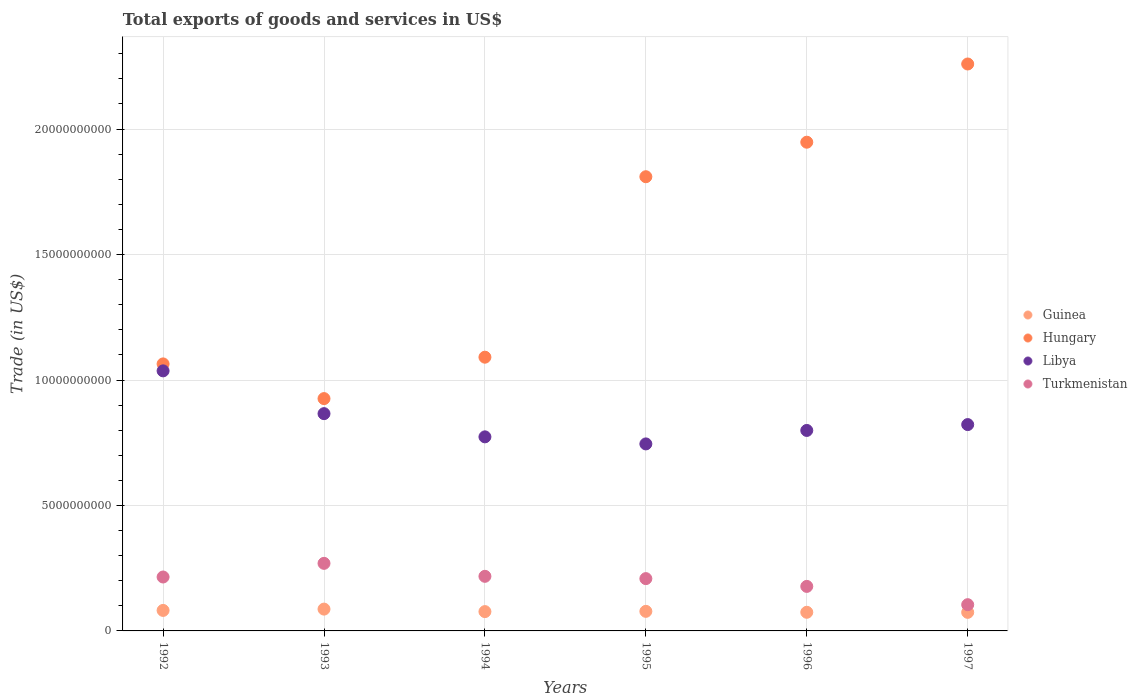How many different coloured dotlines are there?
Ensure brevity in your answer.  4. What is the total exports of goods and services in Libya in 1997?
Provide a short and direct response. 8.22e+09. Across all years, what is the maximum total exports of goods and services in Guinea?
Keep it short and to the point. 8.70e+08. Across all years, what is the minimum total exports of goods and services in Hungary?
Ensure brevity in your answer.  9.26e+09. In which year was the total exports of goods and services in Turkmenistan minimum?
Offer a terse response. 1997. What is the total total exports of goods and services in Hungary in the graph?
Make the answer very short. 9.10e+1. What is the difference between the total exports of goods and services in Hungary in 1993 and that in 1997?
Offer a terse response. -1.33e+1. What is the difference between the total exports of goods and services in Guinea in 1994 and the total exports of goods and services in Turkmenistan in 1997?
Make the answer very short. -2.76e+08. What is the average total exports of goods and services in Turkmenistan per year?
Offer a very short reply. 1.99e+09. In the year 1997, what is the difference between the total exports of goods and services in Guinea and total exports of goods and services in Hungary?
Provide a succinct answer. -2.19e+1. What is the ratio of the total exports of goods and services in Guinea in 1993 to that in 1997?
Provide a short and direct response. 1.17. Is the total exports of goods and services in Libya in 1993 less than that in 1996?
Ensure brevity in your answer.  No. Is the difference between the total exports of goods and services in Guinea in 1993 and 1997 greater than the difference between the total exports of goods and services in Hungary in 1993 and 1997?
Provide a succinct answer. Yes. What is the difference between the highest and the second highest total exports of goods and services in Libya?
Keep it short and to the point. 1.70e+09. What is the difference between the highest and the lowest total exports of goods and services in Libya?
Offer a terse response. 2.91e+09. In how many years, is the total exports of goods and services in Hungary greater than the average total exports of goods and services in Hungary taken over all years?
Your response must be concise. 3. Is it the case that in every year, the sum of the total exports of goods and services in Hungary and total exports of goods and services in Libya  is greater than the sum of total exports of goods and services in Guinea and total exports of goods and services in Turkmenistan?
Keep it short and to the point. No. Is it the case that in every year, the sum of the total exports of goods and services in Guinea and total exports of goods and services in Hungary  is greater than the total exports of goods and services in Turkmenistan?
Provide a succinct answer. Yes. Is the total exports of goods and services in Guinea strictly greater than the total exports of goods and services in Libya over the years?
Make the answer very short. No. What is the difference between two consecutive major ticks on the Y-axis?
Provide a succinct answer. 5.00e+09. Does the graph contain any zero values?
Provide a short and direct response. No. Does the graph contain grids?
Provide a short and direct response. Yes. How many legend labels are there?
Provide a short and direct response. 4. How are the legend labels stacked?
Offer a terse response. Vertical. What is the title of the graph?
Your answer should be compact. Total exports of goods and services in US$. Does "Belize" appear as one of the legend labels in the graph?
Your answer should be compact. No. What is the label or title of the Y-axis?
Offer a terse response. Trade (in US$). What is the Trade (in US$) of Guinea in 1992?
Your answer should be very brief. 8.17e+08. What is the Trade (in US$) of Hungary in 1992?
Provide a short and direct response. 1.06e+1. What is the Trade (in US$) of Libya in 1992?
Make the answer very short. 1.04e+1. What is the Trade (in US$) of Turkmenistan in 1992?
Your response must be concise. 2.15e+09. What is the Trade (in US$) of Guinea in 1993?
Your answer should be very brief. 8.70e+08. What is the Trade (in US$) of Hungary in 1993?
Your response must be concise. 9.26e+09. What is the Trade (in US$) in Libya in 1993?
Your response must be concise. 8.66e+09. What is the Trade (in US$) in Turkmenistan in 1993?
Your answer should be very brief. 2.69e+09. What is the Trade (in US$) of Guinea in 1994?
Your answer should be compact. 7.70e+08. What is the Trade (in US$) of Hungary in 1994?
Your answer should be very brief. 1.09e+1. What is the Trade (in US$) of Libya in 1994?
Provide a short and direct response. 7.73e+09. What is the Trade (in US$) of Turkmenistan in 1994?
Give a very brief answer. 2.18e+09. What is the Trade (in US$) in Guinea in 1995?
Offer a terse response. 7.80e+08. What is the Trade (in US$) of Hungary in 1995?
Provide a short and direct response. 1.81e+1. What is the Trade (in US$) of Libya in 1995?
Provide a succinct answer. 7.45e+09. What is the Trade (in US$) in Turkmenistan in 1995?
Provide a succinct answer. 2.08e+09. What is the Trade (in US$) in Guinea in 1996?
Your answer should be very brief. 7.43e+08. What is the Trade (in US$) in Hungary in 1996?
Provide a succinct answer. 1.95e+1. What is the Trade (in US$) of Libya in 1996?
Provide a short and direct response. 7.99e+09. What is the Trade (in US$) in Turkmenistan in 1996?
Provide a short and direct response. 1.77e+09. What is the Trade (in US$) of Guinea in 1997?
Make the answer very short. 7.40e+08. What is the Trade (in US$) of Hungary in 1997?
Offer a very short reply. 2.26e+1. What is the Trade (in US$) of Libya in 1997?
Ensure brevity in your answer.  8.22e+09. What is the Trade (in US$) of Turkmenistan in 1997?
Give a very brief answer. 1.05e+09. Across all years, what is the maximum Trade (in US$) in Guinea?
Your answer should be very brief. 8.70e+08. Across all years, what is the maximum Trade (in US$) in Hungary?
Keep it short and to the point. 2.26e+1. Across all years, what is the maximum Trade (in US$) in Libya?
Keep it short and to the point. 1.04e+1. Across all years, what is the maximum Trade (in US$) of Turkmenistan?
Offer a terse response. 2.69e+09. Across all years, what is the minimum Trade (in US$) in Guinea?
Give a very brief answer. 7.40e+08. Across all years, what is the minimum Trade (in US$) in Hungary?
Offer a terse response. 9.26e+09. Across all years, what is the minimum Trade (in US$) of Libya?
Provide a succinct answer. 7.45e+09. Across all years, what is the minimum Trade (in US$) of Turkmenistan?
Keep it short and to the point. 1.05e+09. What is the total Trade (in US$) in Guinea in the graph?
Ensure brevity in your answer.  4.72e+09. What is the total Trade (in US$) of Hungary in the graph?
Ensure brevity in your answer.  9.10e+1. What is the total Trade (in US$) in Libya in the graph?
Provide a short and direct response. 5.04e+1. What is the total Trade (in US$) in Turkmenistan in the graph?
Make the answer very short. 1.19e+1. What is the difference between the Trade (in US$) of Guinea in 1992 and that in 1993?
Your answer should be very brief. -5.25e+07. What is the difference between the Trade (in US$) of Hungary in 1992 and that in 1993?
Give a very brief answer. 1.38e+09. What is the difference between the Trade (in US$) of Libya in 1992 and that in 1993?
Offer a terse response. 1.70e+09. What is the difference between the Trade (in US$) in Turkmenistan in 1992 and that in 1993?
Keep it short and to the point. -5.44e+08. What is the difference between the Trade (in US$) in Guinea in 1992 and that in 1994?
Offer a very short reply. 4.73e+07. What is the difference between the Trade (in US$) of Hungary in 1992 and that in 1994?
Ensure brevity in your answer.  -2.68e+08. What is the difference between the Trade (in US$) in Libya in 1992 and that in 1994?
Your answer should be compact. 2.63e+09. What is the difference between the Trade (in US$) of Turkmenistan in 1992 and that in 1994?
Your answer should be very brief. -2.69e+07. What is the difference between the Trade (in US$) in Guinea in 1992 and that in 1995?
Ensure brevity in your answer.  3.70e+07. What is the difference between the Trade (in US$) of Hungary in 1992 and that in 1995?
Provide a succinct answer. -7.46e+09. What is the difference between the Trade (in US$) of Libya in 1992 and that in 1995?
Your answer should be compact. 2.91e+09. What is the difference between the Trade (in US$) of Turkmenistan in 1992 and that in 1995?
Offer a very short reply. 6.45e+07. What is the difference between the Trade (in US$) in Guinea in 1992 and that in 1996?
Give a very brief answer. 7.44e+07. What is the difference between the Trade (in US$) in Hungary in 1992 and that in 1996?
Offer a terse response. -8.84e+09. What is the difference between the Trade (in US$) of Libya in 1992 and that in 1996?
Your response must be concise. 2.37e+09. What is the difference between the Trade (in US$) of Turkmenistan in 1992 and that in 1996?
Keep it short and to the point. 3.74e+08. What is the difference between the Trade (in US$) of Guinea in 1992 and that in 1997?
Your answer should be very brief. 7.69e+07. What is the difference between the Trade (in US$) in Hungary in 1992 and that in 1997?
Provide a succinct answer. -1.20e+1. What is the difference between the Trade (in US$) in Libya in 1992 and that in 1997?
Offer a very short reply. 2.14e+09. What is the difference between the Trade (in US$) in Turkmenistan in 1992 and that in 1997?
Your answer should be compact. 1.10e+09. What is the difference between the Trade (in US$) of Guinea in 1993 and that in 1994?
Offer a very short reply. 9.98e+07. What is the difference between the Trade (in US$) of Hungary in 1993 and that in 1994?
Your answer should be very brief. -1.65e+09. What is the difference between the Trade (in US$) of Libya in 1993 and that in 1994?
Make the answer very short. 9.25e+08. What is the difference between the Trade (in US$) in Turkmenistan in 1993 and that in 1994?
Keep it short and to the point. 5.17e+08. What is the difference between the Trade (in US$) in Guinea in 1993 and that in 1995?
Provide a short and direct response. 8.95e+07. What is the difference between the Trade (in US$) in Hungary in 1993 and that in 1995?
Offer a very short reply. -8.84e+09. What is the difference between the Trade (in US$) of Libya in 1993 and that in 1995?
Keep it short and to the point. 1.21e+09. What is the difference between the Trade (in US$) in Turkmenistan in 1993 and that in 1995?
Provide a succinct answer. 6.08e+08. What is the difference between the Trade (in US$) in Guinea in 1993 and that in 1996?
Your response must be concise. 1.27e+08. What is the difference between the Trade (in US$) in Hungary in 1993 and that in 1996?
Offer a terse response. -1.02e+1. What is the difference between the Trade (in US$) of Libya in 1993 and that in 1996?
Your answer should be very brief. 6.69e+08. What is the difference between the Trade (in US$) in Turkmenistan in 1993 and that in 1996?
Offer a terse response. 9.18e+08. What is the difference between the Trade (in US$) of Guinea in 1993 and that in 1997?
Provide a succinct answer. 1.29e+08. What is the difference between the Trade (in US$) in Hungary in 1993 and that in 1997?
Keep it short and to the point. -1.33e+1. What is the difference between the Trade (in US$) of Libya in 1993 and that in 1997?
Offer a terse response. 4.36e+08. What is the difference between the Trade (in US$) in Turkmenistan in 1993 and that in 1997?
Your answer should be compact. 1.65e+09. What is the difference between the Trade (in US$) in Guinea in 1994 and that in 1995?
Offer a terse response. -1.03e+07. What is the difference between the Trade (in US$) in Hungary in 1994 and that in 1995?
Provide a short and direct response. -7.19e+09. What is the difference between the Trade (in US$) in Libya in 1994 and that in 1995?
Provide a short and direct response. 2.81e+08. What is the difference between the Trade (in US$) of Turkmenistan in 1994 and that in 1995?
Provide a short and direct response. 9.14e+07. What is the difference between the Trade (in US$) of Guinea in 1994 and that in 1996?
Ensure brevity in your answer.  2.71e+07. What is the difference between the Trade (in US$) in Hungary in 1994 and that in 1996?
Provide a short and direct response. -8.57e+09. What is the difference between the Trade (in US$) in Libya in 1994 and that in 1996?
Give a very brief answer. -2.56e+08. What is the difference between the Trade (in US$) in Turkmenistan in 1994 and that in 1996?
Your answer should be very brief. 4.01e+08. What is the difference between the Trade (in US$) in Guinea in 1994 and that in 1997?
Offer a terse response. 2.96e+07. What is the difference between the Trade (in US$) of Hungary in 1994 and that in 1997?
Your response must be concise. -1.17e+1. What is the difference between the Trade (in US$) in Libya in 1994 and that in 1997?
Offer a very short reply. -4.89e+08. What is the difference between the Trade (in US$) in Turkmenistan in 1994 and that in 1997?
Offer a very short reply. 1.13e+09. What is the difference between the Trade (in US$) of Guinea in 1995 and that in 1996?
Your response must be concise. 3.74e+07. What is the difference between the Trade (in US$) in Hungary in 1995 and that in 1996?
Offer a very short reply. -1.38e+09. What is the difference between the Trade (in US$) of Libya in 1995 and that in 1996?
Your answer should be compact. -5.37e+08. What is the difference between the Trade (in US$) of Turkmenistan in 1995 and that in 1996?
Offer a very short reply. 3.10e+08. What is the difference between the Trade (in US$) of Guinea in 1995 and that in 1997?
Your answer should be compact. 3.99e+07. What is the difference between the Trade (in US$) of Hungary in 1995 and that in 1997?
Offer a very short reply. -4.49e+09. What is the difference between the Trade (in US$) in Libya in 1995 and that in 1997?
Provide a short and direct response. -7.70e+08. What is the difference between the Trade (in US$) in Turkmenistan in 1995 and that in 1997?
Offer a very short reply. 1.04e+09. What is the difference between the Trade (in US$) in Guinea in 1996 and that in 1997?
Offer a very short reply. 2.51e+06. What is the difference between the Trade (in US$) of Hungary in 1996 and that in 1997?
Your answer should be very brief. -3.12e+09. What is the difference between the Trade (in US$) in Libya in 1996 and that in 1997?
Your answer should be very brief. -2.33e+08. What is the difference between the Trade (in US$) of Turkmenistan in 1996 and that in 1997?
Offer a very short reply. 7.29e+08. What is the difference between the Trade (in US$) in Guinea in 1992 and the Trade (in US$) in Hungary in 1993?
Offer a very short reply. -8.44e+09. What is the difference between the Trade (in US$) in Guinea in 1992 and the Trade (in US$) in Libya in 1993?
Offer a very short reply. -7.84e+09. What is the difference between the Trade (in US$) of Guinea in 1992 and the Trade (in US$) of Turkmenistan in 1993?
Make the answer very short. -1.88e+09. What is the difference between the Trade (in US$) in Hungary in 1992 and the Trade (in US$) in Libya in 1993?
Provide a succinct answer. 1.98e+09. What is the difference between the Trade (in US$) of Hungary in 1992 and the Trade (in US$) of Turkmenistan in 1993?
Offer a terse response. 7.95e+09. What is the difference between the Trade (in US$) of Libya in 1992 and the Trade (in US$) of Turkmenistan in 1993?
Make the answer very short. 7.67e+09. What is the difference between the Trade (in US$) in Guinea in 1992 and the Trade (in US$) in Hungary in 1994?
Your answer should be very brief. -1.01e+1. What is the difference between the Trade (in US$) of Guinea in 1992 and the Trade (in US$) of Libya in 1994?
Keep it short and to the point. -6.92e+09. What is the difference between the Trade (in US$) of Guinea in 1992 and the Trade (in US$) of Turkmenistan in 1994?
Offer a terse response. -1.36e+09. What is the difference between the Trade (in US$) of Hungary in 1992 and the Trade (in US$) of Libya in 1994?
Provide a succinct answer. 2.91e+09. What is the difference between the Trade (in US$) in Hungary in 1992 and the Trade (in US$) in Turkmenistan in 1994?
Give a very brief answer. 8.47e+09. What is the difference between the Trade (in US$) in Libya in 1992 and the Trade (in US$) in Turkmenistan in 1994?
Provide a short and direct response. 8.19e+09. What is the difference between the Trade (in US$) of Guinea in 1992 and the Trade (in US$) of Hungary in 1995?
Keep it short and to the point. -1.73e+1. What is the difference between the Trade (in US$) in Guinea in 1992 and the Trade (in US$) in Libya in 1995?
Offer a terse response. -6.64e+09. What is the difference between the Trade (in US$) of Guinea in 1992 and the Trade (in US$) of Turkmenistan in 1995?
Your answer should be very brief. -1.27e+09. What is the difference between the Trade (in US$) of Hungary in 1992 and the Trade (in US$) of Libya in 1995?
Keep it short and to the point. 3.19e+09. What is the difference between the Trade (in US$) in Hungary in 1992 and the Trade (in US$) in Turkmenistan in 1995?
Give a very brief answer. 8.56e+09. What is the difference between the Trade (in US$) in Libya in 1992 and the Trade (in US$) in Turkmenistan in 1995?
Provide a succinct answer. 8.28e+09. What is the difference between the Trade (in US$) of Guinea in 1992 and the Trade (in US$) of Hungary in 1996?
Offer a very short reply. -1.87e+1. What is the difference between the Trade (in US$) of Guinea in 1992 and the Trade (in US$) of Libya in 1996?
Ensure brevity in your answer.  -7.17e+09. What is the difference between the Trade (in US$) of Guinea in 1992 and the Trade (in US$) of Turkmenistan in 1996?
Offer a very short reply. -9.57e+08. What is the difference between the Trade (in US$) in Hungary in 1992 and the Trade (in US$) in Libya in 1996?
Give a very brief answer. 2.65e+09. What is the difference between the Trade (in US$) of Hungary in 1992 and the Trade (in US$) of Turkmenistan in 1996?
Ensure brevity in your answer.  8.87e+09. What is the difference between the Trade (in US$) in Libya in 1992 and the Trade (in US$) in Turkmenistan in 1996?
Provide a short and direct response. 8.59e+09. What is the difference between the Trade (in US$) of Guinea in 1992 and the Trade (in US$) of Hungary in 1997?
Make the answer very short. -2.18e+1. What is the difference between the Trade (in US$) of Guinea in 1992 and the Trade (in US$) of Libya in 1997?
Make the answer very short. -7.41e+09. What is the difference between the Trade (in US$) of Guinea in 1992 and the Trade (in US$) of Turkmenistan in 1997?
Your answer should be very brief. -2.29e+08. What is the difference between the Trade (in US$) of Hungary in 1992 and the Trade (in US$) of Libya in 1997?
Offer a terse response. 2.42e+09. What is the difference between the Trade (in US$) in Hungary in 1992 and the Trade (in US$) in Turkmenistan in 1997?
Ensure brevity in your answer.  9.60e+09. What is the difference between the Trade (in US$) of Libya in 1992 and the Trade (in US$) of Turkmenistan in 1997?
Give a very brief answer. 9.32e+09. What is the difference between the Trade (in US$) in Guinea in 1993 and the Trade (in US$) in Hungary in 1994?
Your response must be concise. -1.00e+1. What is the difference between the Trade (in US$) in Guinea in 1993 and the Trade (in US$) in Libya in 1994?
Keep it short and to the point. -6.86e+09. What is the difference between the Trade (in US$) in Guinea in 1993 and the Trade (in US$) in Turkmenistan in 1994?
Offer a terse response. -1.31e+09. What is the difference between the Trade (in US$) in Hungary in 1993 and the Trade (in US$) in Libya in 1994?
Provide a short and direct response. 1.52e+09. What is the difference between the Trade (in US$) of Hungary in 1993 and the Trade (in US$) of Turkmenistan in 1994?
Offer a terse response. 7.08e+09. What is the difference between the Trade (in US$) of Libya in 1993 and the Trade (in US$) of Turkmenistan in 1994?
Provide a succinct answer. 6.48e+09. What is the difference between the Trade (in US$) of Guinea in 1993 and the Trade (in US$) of Hungary in 1995?
Your answer should be very brief. -1.72e+1. What is the difference between the Trade (in US$) in Guinea in 1993 and the Trade (in US$) in Libya in 1995?
Your answer should be very brief. -6.58e+09. What is the difference between the Trade (in US$) in Guinea in 1993 and the Trade (in US$) in Turkmenistan in 1995?
Offer a terse response. -1.21e+09. What is the difference between the Trade (in US$) of Hungary in 1993 and the Trade (in US$) of Libya in 1995?
Your answer should be compact. 1.81e+09. What is the difference between the Trade (in US$) of Hungary in 1993 and the Trade (in US$) of Turkmenistan in 1995?
Your answer should be very brief. 7.17e+09. What is the difference between the Trade (in US$) of Libya in 1993 and the Trade (in US$) of Turkmenistan in 1995?
Make the answer very short. 6.57e+09. What is the difference between the Trade (in US$) in Guinea in 1993 and the Trade (in US$) in Hungary in 1996?
Your answer should be compact. -1.86e+1. What is the difference between the Trade (in US$) of Guinea in 1993 and the Trade (in US$) of Libya in 1996?
Provide a short and direct response. -7.12e+09. What is the difference between the Trade (in US$) in Guinea in 1993 and the Trade (in US$) in Turkmenistan in 1996?
Ensure brevity in your answer.  -9.05e+08. What is the difference between the Trade (in US$) in Hungary in 1993 and the Trade (in US$) in Libya in 1996?
Provide a short and direct response. 1.27e+09. What is the difference between the Trade (in US$) of Hungary in 1993 and the Trade (in US$) of Turkmenistan in 1996?
Your answer should be very brief. 7.48e+09. What is the difference between the Trade (in US$) in Libya in 1993 and the Trade (in US$) in Turkmenistan in 1996?
Your answer should be compact. 6.88e+09. What is the difference between the Trade (in US$) of Guinea in 1993 and the Trade (in US$) of Hungary in 1997?
Keep it short and to the point. -2.17e+1. What is the difference between the Trade (in US$) of Guinea in 1993 and the Trade (in US$) of Libya in 1997?
Provide a short and direct response. -7.35e+09. What is the difference between the Trade (in US$) in Guinea in 1993 and the Trade (in US$) in Turkmenistan in 1997?
Provide a succinct answer. -1.76e+08. What is the difference between the Trade (in US$) in Hungary in 1993 and the Trade (in US$) in Libya in 1997?
Provide a succinct answer. 1.04e+09. What is the difference between the Trade (in US$) in Hungary in 1993 and the Trade (in US$) in Turkmenistan in 1997?
Offer a very short reply. 8.21e+09. What is the difference between the Trade (in US$) of Libya in 1993 and the Trade (in US$) of Turkmenistan in 1997?
Offer a terse response. 7.61e+09. What is the difference between the Trade (in US$) in Guinea in 1994 and the Trade (in US$) in Hungary in 1995?
Your answer should be very brief. -1.73e+1. What is the difference between the Trade (in US$) in Guinea in 1994 and the Trade (in US$) in Libya in 1995?
Keep it short and to the point. -6.68e+09. What is the difference between the Trade (in US$) of Guinea in 1994 and the Trade (in US$) of Turkmenistan in 1995?
Make the answer very short. -1.31e+09. What is the difference between the Trade (in US$) in Hungary in 1994 and the Trade (in US$) in Libya in 1995?
Make the answer very short. 3.46e+09. What is the difference between the Trade (in US$) of Hungary in 1994 and the Trade (in US$) of Turkmenistan in 1995?
Give a very brief answer. 8.82e+09. What is the difference between the Trade (in US$) in Libya in 1994 and the Trade (in US$) in Turkmenistan in 1995?
Ensure brevity in your answer.  5.65e+09. What is the difference between the Trade (in US$) in Guinea in 1994 and the Trade (in US$) in Hungary in 1996?
Ensure brevity in your answer.  -1.87e+1. What is the difference between the Trade (in US$) in Guinea in 1994 and the Trade (in US$) in Libya in 1996?
Ensure brevity in your answer.  -7.22e+09. What is the difference between the Trade (in US$) in Guinea in 1994 and the Trade (in US$) in Turkmenistan in 1996?
Offer a very short reply. -1.00e+09. What is the difference between the Trade (in US$) in Hungary in 1994 and the Trade (in US$) in Libya in 1996?
Keep it short and to the point. 2.92e+09. What is the difference between the Trade (in US$) in Hungary in 1994 and the Trade (in US$) in Turkmenistan in 1996?
Give a very brief answer. 9.13e+09. What is the difference between the Trade (in US$) of Libya in 1994 and the Trade (in US$) of Turkmenistan in 1996?
Make the answer very short. 5.96e+09. What is the difference between the Trade (in US$) of Guinea in 1994 and the Trade (in US$) of Hungary in 1997?
Your response must be concise. -2.18e+1. What is the difference between the Trade (in US$) of Guinea in 1994 and the Trade (in US$) of Libya in 1997?
Give a very brief answer. -7.45e+09. What is the difference between the Trade (in US$) in Guinea in 1994 and the Trade (in US$) in Turkmenistan in 1997?
Provide a succinct answer. -2.76e+08. What is the difference between the Trade (in US$) of Hungary in 1994 and the Trade (in US$) of Libya in 1997?
Keep it short and to the point. 2.69e+09. What is the difference between the Trade (in US$) of Hungary in 1994 and the Trade (in US$) of Turkmenistan in 1997?
Your answer should be compact. 9.86e+09. What is the difference between the Trade (in US$) in Libya in 1994 and the Trade (in US$) in Turkmenistan in 1997?
Provide a short and direct response. 6.69e+09. What is the difference between the Trade (in US$) in Guinea in 1995 and the Trade (in US$) in Hungary in 1996?
Provide a short and direct response. -1.87e+1. What is the difference between the Trade (in US$) in Guinea in 1995 and the Trade (in US$) in Libya in 1996?
Offer a terse response. -7.21e+09. What is the difference between the Trade (in US$) of Guinea in 1995 and the Trade (in US$) of Turkmenistan in 1996?
Offer a very short reply. -9.94e+08. What is the difference between the Trade (in US$) of Hungary in 1995 and the Trade (in US$) of Libya in 1996?
Ensure brevity in your answer.  1.01e+1. What is the difference between the Trade (in US$) of Hungary in 1995 and the Trade (in US$) of Turkmenistan in 1996?
Your response must be concise. 1.63e+1. What is the difference between the Trade (in US$) of Libya in 1995 and the Trade (in US$) of Turkmenistan in 1996?
Provide a short and direct response. 5.68e+09. What is the difference between the Trade (in US$) in Guinea in 1995 and the Trade (in US$) in Hungary in 1997?
Your answer should be compact. -2.18e+1. What is the difference between the Trade (in US$) in Guinea in 1995 and the Trade (in US$) in Libya in 1997?
Make the answer very short. -7.44e+09. What is the difference between the Trade (in US$) in Guinea in 1995 and the Trade (in US$) in Turkmenistan in 1997?
Make the answer very short. -2.66e+08. What is the difference between the Trade (in US$) in Hungary in 1995 and the Trade (in US$) in Libya in 1997?
Your answer should be compact. 9.88e+09. What is the difference between the Trade (in US$) of Hungary in 1995 and the Trade (in US$) of Turkmenistan in 1997?
Offer a terse response. 1.71e+1. What is the difference between the Trade (in US$) of Libya in 1995 and the Trade (in US$) of Turkmenistan in 1997?
Your answer should be compact. 6.41e+09. What is the difference between the Trade (in US$) in Guinea in 1996 and the Trade (in US$) in Hungary in 1997?
Your response must be concise. -2.19e+1. What is the difference between the Trade (in US$) in Guinea in 1996 and the Trade (in US$) in Libya in 1997?
Ensure brevity in your answer.  -7.48e+09. What is the difference between the Trade (in US$) in Guinea in 1996 and the Trade (in US$) in Turkmenistan in 1997?
Keep it short and to the point. -3.03e+08. What is the difference between the Trade (in US$) in Hungary in 1996 and the Trade (in US$) in Libya in 1997?
Provide a succinct answer. 1.13e+1. What is the difference between the Trade (in US$) in Hungary in 1996 and the Trade (in US$) in Turkmenistan in 1997?
Your answer should be very brief. 1.84e+1. What is the difference between the Trade (in US$) of Libya in 1996 and the Trade (in US$) of Turkmenistan in 1997?
Your response must be concise. 6.94e+09. What is the average Trade (in US$) in Guinea per year?
Your answer should be very brief. 7.87e+08. What is the average Trade (in US$) of Hungary per year?
Offer a very short reply. 1.52e+1. What is the average Trade (in US$) in Libya per year?
Offer a very short reply. 8.40e+09. What is the average Trade (in US$) in Turkmenistan per year?
Offer a terse response. 1.99e+09. In the year 1992, what is the difference between the Trade (in US$) in Guinea and Trade (in US$) in Hungary?
Your response must be concise. -9.82e+09. In the year 1992, what is the difference between the Trade (in US$) in Guinea and Trade (in US$) in Libya?
Your answer should be compact. -9.55e+09. In the year 1992, what is the difference between the Trade (in US$) of Guinea and Trade (in US$) of Turkmenistan?
Provide a short and direct response. -1.33e+09. In the year 1992, what is the difference between the Trade (in US$) of Hungary and Trade (in US$) of Libya?
Offer a terse response. 2.77e+08. In the year 1992, what is the difference between the Trade (in US$) in Hungary and Trade (in US$) in Turkmenistan?
Keep it short and to the point. 8.49e+09. In the year 1992, what is the difference between the Trade (in US$) of Libya and Trade (in US$) of Turkmenistan?
Give a very brief answer. 8.22e+09. In the year 1993, what is the difference between the Trade (in US$) of Guinea and Trade (in US$) of Hungary?
Offer a very short reply. -8.39e+09. In the year 1993, what is the difference between the Trade (in US$) in Guinea and Trade (in US$) in Libya?
Offer a terse response. -7.79e+09. In the year 1993, what is the difference between the Trade (in US$) of Guinea and Trade (in US$) of Turkmenistan?
Your answer should be compact. -1.82e+09. In the year 1993, what is the difference between the Trade (in US$) in Hungary and Trade (in US$) in Libya?
Make the answer very short. 6.00e+08. In the year 1993, what is the difference between the Trade (in US$) of Hungary and Trade (in US$) of Turkmenistan?
Your answer should be very brief. 6.57e+09. In the year 1993, what is the difference between the Trade (in US$) in Libya and Trade (in US$) in Turkmenistan?
Offer a very short reply. 5.97e+09. In the year 1994, what is the difference between the Trade (in US$) of Guinea and Trade (in US$) of Hungary?
Offer a very short reply. -1.01e+1. In the year 1994, what is the difference between the Trade (in US$) of Guinea and Trade (in US$) of Libya?
Make the answer very short. -6.96e+09. In the year 1994, what is the difference between the Trade (in US$) of Guinea and Trade (in US$) of Turkmenistan?
Make the answer very short. -1.41e+09. In the year 1994, what is the difference between the Trade (in US$) of Hungary and Trade (in US$) of Libya?
Your answer should be compact. 3.17e+09. In the year 1994, what is the difference between the Trade (in US$) in Hungary and Trade (in US$) in Turkmenistan?
Make the answer very short. 8.73e+09. In the year 1994, what is the difference between the Trade (in US$) of Libya and Trade (in US$) of Turkmenistan?
Your answer should be very brief. 5.56e+09. In the year 1995, what is the difference between the Trade (in US$) in Guinea and Trade (in US$) in Hungary?
Your answer should be very brief. -1.73e+1. In the year 1995, what is the difference between the Trade (in US$) in Guinea and Trade (in US$) in Libya?
Offer a terse response. -6.67e+09. In the year 1995, what is the difference between the Trade (in US$) of Guinea and Trade (in US$) of Turkmenistan?
Provide a short and direct response. -1.30e+09. In the year 1995, what is the difference between the Trade (in US$) in Hungary and Trade (in US$) in Libya?
Offer a very short reply. 1.06e+1. In the year 1995, what is the difference between the Trade (in US$) of Hungary and Trade (in US$) of Turkmenistan?
Your response must be concise. 1.60e+1. In the year 1995, what is the difference between the Trade (in US$) of Libya and Trade (in US$) of Turkmenistan?
Provide a succinct answer. 5.37e+09. In the year 1996, what is the difference between the Trade (in US$) of Guinea and Trade (in US$) of Hungary?
Ensure brevity in your answer.  -1.87e+1. In the year 1996, what is the difference between the Trade (in US$) in Guinea and Trade (in US$) in Libya?
Your answer should be compact. -7.25e+09. In the year 1996, what is the difference between the Trade (in US$) of Guinea and Trade (in US$) of Turkmenistan?
Your answer should be compact. -1.03e+09. In the year 1996, what is the difference between the Trade (in US$) in Hungary and Trade (in US$) in Libya?
Your answer should be very brief. 1.15e+1. In the year 1996, what is the difference between the Trade (in US$) in Hungary and Trade (in US$) in Turkmenistan?
Ensure brevity in your answer.  1.77e+1. In the year 1996, what is the difference between the Trade (in US$) of Libya and Trade (in US$) of Turkmenistan?
Your response must be concise. 6.22e+09. In the year 1997, what is the difference between the Trade (in US$) of Guinea and Trade (in US$) of Hungary?
Offer a terse response. -2.19e+1. In the year 1997, what is the difference between the Trade (in US$) of Guinea and Trade (in US$) of Libya?
Provide a short and direct response. -7.48e+09. In the year 1997, what is the difference between the Trade (in US$) in Guinea and Trade (in US$) in Turkmenistan?
Offer a terse response. -3.06e+08. In the year 1997, what is the difference between the Trade (in US$) in Hungary and Trade (in US$) in Libya?
Provide a short and direct response. 1.44e+1. In the year 1997, what is the difference between the Trade (in US$) of Hungary and Trade (in US$) of Turkmenistan?
Provide a short and direct response. 2.15e+1. In the year 1997, what is the difference between the Trade (in US$) of Libya and Trade (in US$) of Turkmenistan?
Your response must be concise. 7.18e+09. What is the ratio of the Trade (in US$) in Guinea in 1992 to that in 1993?
Offer a very short reply. 0.94. What is the ratio of the Trade (in US$) of Hungary in 1992 to that in 1993?
Your answer should be very brief. 1.15. What is the ratio of the Trade (in US$) of Libya in 1992 to that in 1993?
Give a very brief answer. 1.2. What is the ratio of the Trade (in US$) in Turkmenistan in 1992 to that in 1993?
Offer a very short reply. 0.8. What is the ratio of the Trade (in US$) of Guinea in 1992 to that in 1994?
Make the answer very short. 1.06. What is the ratio of the Trade (in US$) in Hungary in 1992 to that in 1994?
Your answer should be very brief. 0.98. What is the ratio of the Trade (in US$) of Libya in 1992 to that in 1994?
Your response must be concise. 1.34. What is the ratio of the Trade (in US$) of Turkmenistan in 1992 to that in 1994?
Your answer should be very brief. 0.99. What is the ratio of the Trade (in US$) in Guinea in 1992 to that in 1995?
Offer a terse response. 1.05. What is the ratio of the Trade (in US$) of Hungary in 1992 to that in 1995?
Ensure brevity in your answer.  0.59. What is the ratio of the Trade (in US$) in Libya in 1992 to that in 1995?
Give a very brief answer. 1.39. What is the ratio of the Trade (in US$) of Turkmenistan in 1992 to that in 1995?
Your answer should be compact. 1.03. What is the ratio of the Trade (in US$) in Guinea in 1992 to that in 1996?
Provide a short and direct response. 1.1. What is the ratio of the Trade (in US$) of Hungary in 1992 to that in 1996?
Offer a very short reply. 0.55. What is the ratio of the Trade (in US$) in Libya in 1992 to that in 1996?
Provide a succinct answer. 1.3. What is the ratio of the Trade (in US$) in Turkmenistan in 1992 to that in 1996?
Your answer should be very brief. 1.21. What is the ratio of the Trade (in US$) in Guinea in 1992 to that in 1997?
Your answer should be very brief. 1.1. What is the ratio of the Trade (in US$) in Hungary in 1992 to that in 1997?
Your answer should be very brief. 0.47. What is the ratio of the Trade (in US$) in Libya in 1992 to that in 1997?
Make the answer very short. 1.26. What is the ratio of the Trade (in US$) in Turkmenistan in 1992 to that in 1997?
Your answer should be very brief. 2.05. What is the ratio of the Trade (in US$) in Guinea in 1993 to that in 1994?
Offer a terse response. 1.13. What is the ratio of the Trade (in US$) of Hungary in 1993 to that in 1994?
Give a very brief answer. 0.85. What is the ratio of the Trade (in US$) in Libya in 1993 to that in 1994?
Give a very brief answer. 1.12. What is the ratio of the Trade (in US$) in Turkmenistan in 1993 to that in 1994?
Your response must be concise. 1.24. What is the ratio of the Trade (in US$) in Guinea in 1993 to that in 1995?
Your answer should be very brief. 1.11. What is the ratio of the Trade (in US$) in Hungary in 1993 to that in 1995?
Give a very brief answer. 0.51. What is the ratio of the Trade (in US$) in Libya in 1993 to that in 1995?
Keep it short and to the point. 1.16. What is the ratio of the Trade (in US$) in Turkmenistan in 1993 to that in 1995?
Offer a terse response. 1.29. What is the ratio of the Trade (in US$) in Guinea in 1993 to that in 1996?
Provide a succinct answer. 1.17. What is the ratio of the Trade (in US$) in Hungary in 1993 to that in 1996?
Your answer should be compact. 0.48. What is the ratio of the Trade (in US$) of Libya in 1993 to that in 1996?
Offer a very short reply. 1.08. What is the ratio of the Trade (in US$) of Turkmenistan in 1993 to that in 1996?
Give a very brief answer. 1.52. What is the ratio of the Trade (in US$) in Guinea in 1993 to that in 1997?
Keep it short and to the point. 1.17. What is the ratio of the Trade (in US$) in Hungary in 1993 to that in 1997?
Your answer should be compact. 0.41. What is the ratio of the Trade (in US$) of Libya in 1993 to that in 1997?
Give a very brief answer. 1.05. What is the ratio of the Trade (in US$) of Turkmenistan in 1993 to that in 1997?
Provide a succinct answer. 2.57. What is the ratio of the Trade (in US$) in Hungary in 1994 to that in 1995?
Give a very brief answer. 0.6. What is the ratio of the Trade (in US$) in Libya in 1994 to that in 1995?
Provide a short and direct response. 1.04. What is the ratio of the Trade (in US$) of Turkmenistan in 1994 to that in 1995?
Give a very brief answer. 1.04. What is the ratio of the Trade (in US$) in Guinea in 1994 to that in 1996?
Give a very brief answer. 1.04. What is the ratio of the Trade (in US$) in Hungary in 1994 to that in 1996?
Keep it short and to the point. 0.56. What is the ratio of the Trade (in US$) of Libya in 1994 to that in 1996?
Your answer should be very brief. 0.97. What is the ratio of the Trade (in US$) in Turkmenistan in 1994 to that in 1996?
Give a very brief answer. 1.23. What is the ratio of the Trade (in US$) of Hungary in 1994 to that in 1997?
Your answer should be very brief. 0.48. What is the ratio of the Trade (in US$) of Libya in 1994 to that in 1997?
Give a very brief answer. 0.94. What is the ratio of the Trade (in US$) of Turkmenistan in 1994 to that in 1997?
Your answer should be very brief. 2.08. What is the ratio of the Trade (in US$) of Guinea in 1995 to that in 1996?
Offer a very short reply. 1.05. What is the ratio of the Trade (in US$) of Hungary in 1995 to that in 1996?
Your answer should be very brief. 0.93. What is the ratio of the Trade (in US$) of Libya in 1995 to that in 1996?
Your response must be concise. 0.93. What is the ratio of the Trade (in US$) in Turkmenistan in 1995 to that in 1996?
Make the answer very short. 1.17. What is the ratio of the Trade (in US$) in Guinea in 1995 to that in 1997?
Your answer should be very brief. 1.05. What is the ratio of the Trade (in US$) of Hungary in 1995 to that in 1997?
Give a very brief answer. 0.8. What is the ratio of the Trade (in US$) of Libya in 1995 to that in 1997?
Your response must be concise. 0.91. What is the ratio of the Trade (in US$) of Turkmenistan in 1995 to that in 1997?
Offer a terse response. 1.99. What is the ratio of the Trade (in US$) of Guinea in 1996 to that in 1997?
Provide a short and direct response. 1. What is the ratio of the Trade (in US$) in Hungary in 1996 to that in 1997?
Give a very brief answer. 0.86. What is the ratio of the Trade (in US$) in Libya in 1996 to that in 1997?
Keep it short and to the point. 0.97. What is the ratio of the Trade (in US$) of Turkmenistan in 1996 to that in 1997?
Your response must be concise. 1.7. What is the difference between the highest and the second highest Trade (in US$) in Guinea?
Your response must be concise. 5.25e+07. What is the difference between the highest and the second highest Trade (in US$) of Hungary?
Provide a succinct answer. 3.12e+09. What is the difference between the highest and the second highest Trade (in US$) of Libya?
Your answer should be very brief. 1.70e+09. What is the difference between the highest and the second highest Trade (in US$) of Turkmenistan?
Provide a short and direct response. 5.17e+08. What is the difference between the highest and the lowest Trade (in US$) of Guinea?
Your answer should be very brief. 1.29e+08. What is the difference between the highest and the lowest Trade (in US$) of Hungary?
Your answer should be very brief. 1.33e+1. What is the difference between the highest and the lowest Trade (in US$) in Libya?
Your answer should be compact. 2.91e+09. What is the difference between the highest and the lowest Trade (in US$) in Turkmenistan?
Keep it short and to the point. 1.65e+09. 